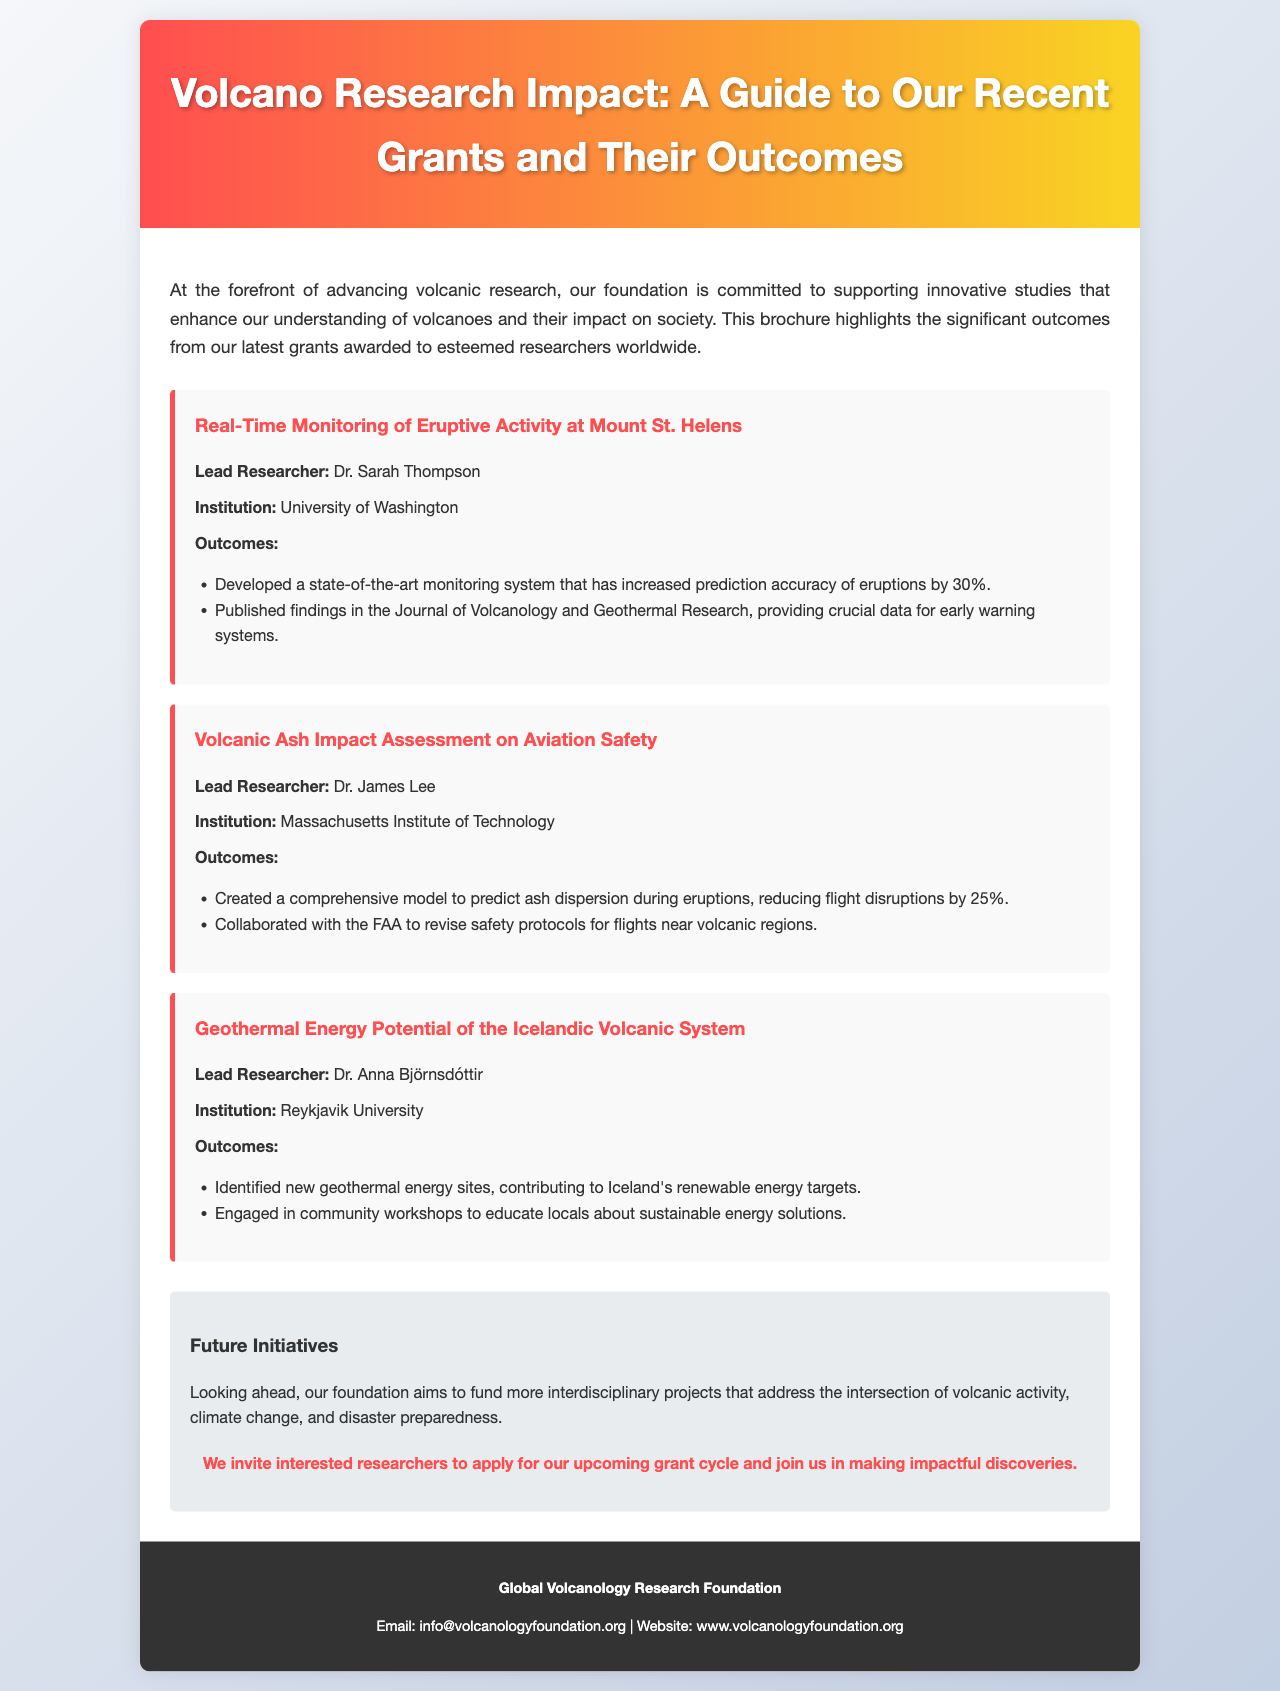What is the title of the brochure? The title of the brochure is prominently displayed at the top of the document.
Answer: Volcano Research Impact: A Guide to Our Recent Grants and Their Outcomes Who is the lead researcher for the grant on volcanic ash impact assessment? The name of the lead researcher for each grant is listed directly under the grant title.
Answer: Dr. James Lee What percentage did the monitoring system increase prediction accuracy for eruptions? The outcome details provided a specific percentage regarding the increase in prediction accuracy.
Answer: 30% Which institution is associated with the lead researcher Dr. Sarah Thompson? The institution is mentioned directly under the lead researcher's name in each grant section.
Answer: University of Washington What is the focus of the future initiatives mentioned in the brochure? The future initiatives section outlines the primary focus area for upcoming funding efforts.
Answer: Interdisciplinary projects What significant contribution did Dr. Anna Björnsdóttir's research make to renewable energy? The document specifies the outcomes of the research related to renewable energy contributions.
Answer: New geothermal energy sites How much did flight disruptions decrease according to Dr. James Lee's research? A specific percentage is provided regarding the reduction in flight disruptions resulting from the research.
Answer: 25% What type of workshops did Dr. Anna Björnsdóttir engage in? The document describes the nature of workshops associated with Dr. Anna Björnsdóttir's research outcomes.
Answer: Community workshops 